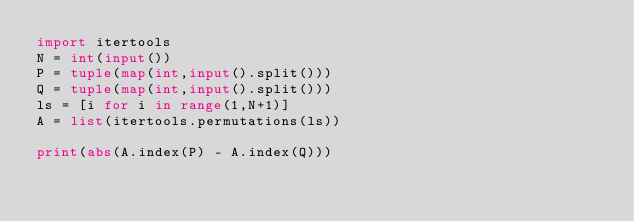Convert code to text. <code><loc_0><loc_0><loc_500><loc_500><_Python_>import itertools
N = int(input())
P = tuple(map(int,input().split()))
Q = tuple(map(int,input().split()))
ls = [i for i in range(1,N+1)]
A = list(itertools.permutations(ls))
 
print(abs(A.index(P) - A.index(Q)))</code> 